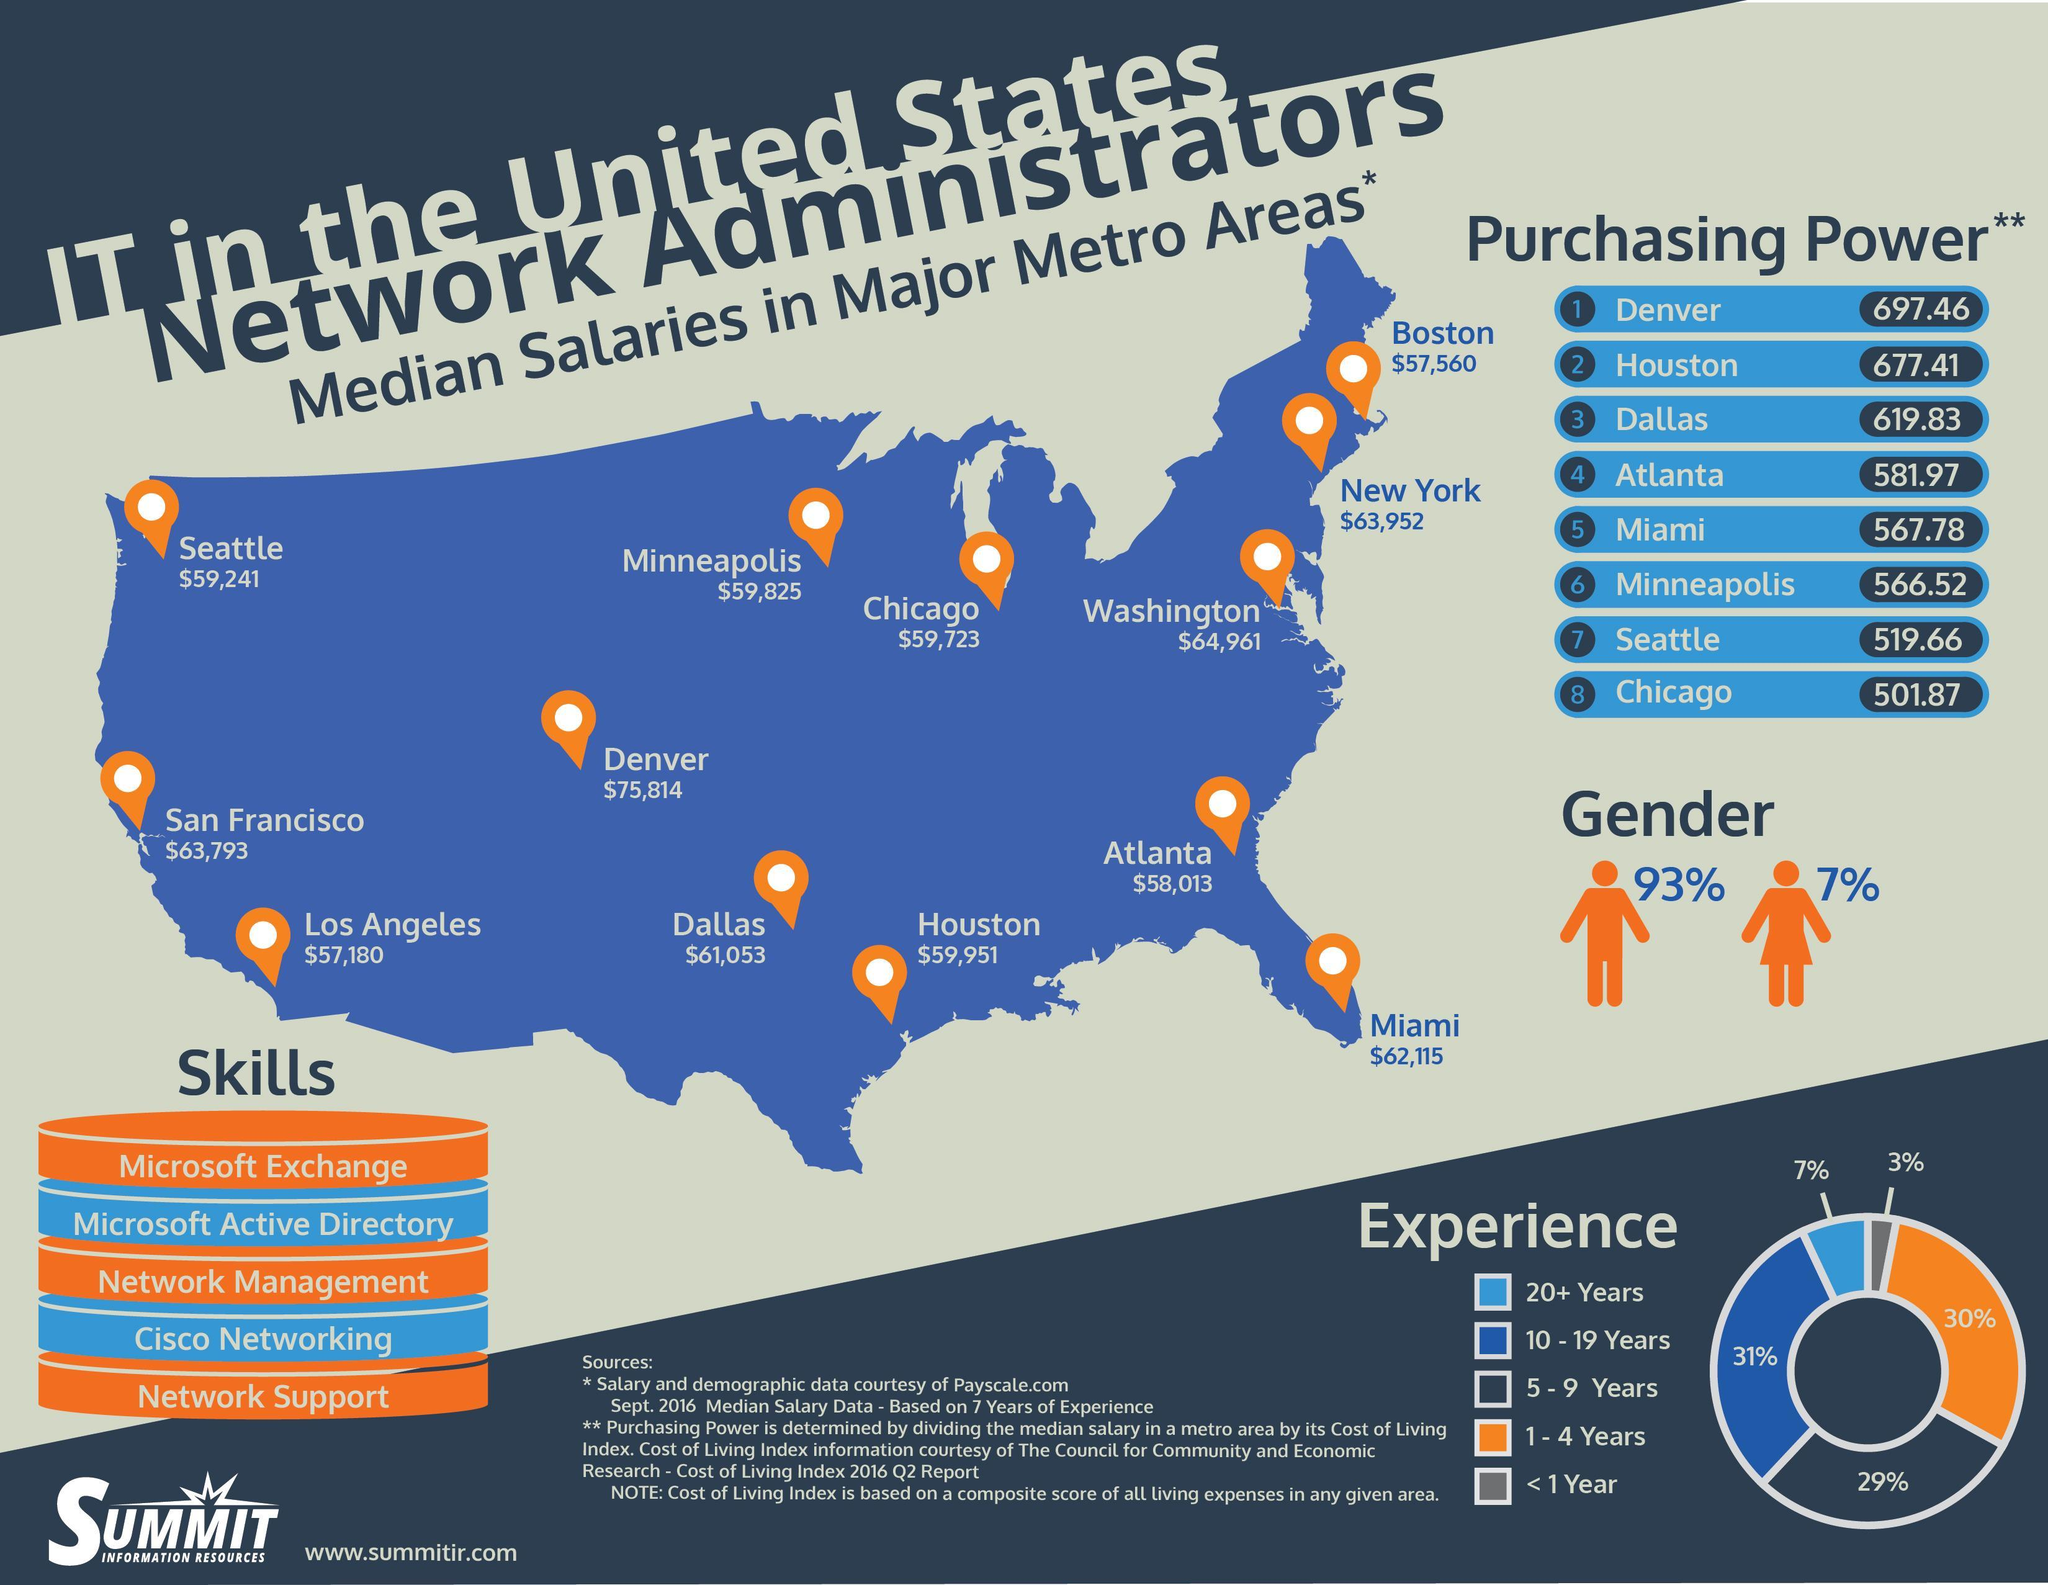What percentage of network administrators in U.S. are males?
Answer the question with a short phrase. 93% What percent of people have 10-19 years of experience as network administrator in U.S? 31% What percent of people have 1-4 years of experience as network administrator in U.S? 30% What is the median salary of network administrators in New York? $63,952 What is the median salary of network administrators in Chicago? $59,723 Which city in U.S. provides the highest median salary for network administrators? Denver What percent of people have 20+ years experience as network administrator in U.S? 7% What percentage of network administrators in U.S. are females? 7% 